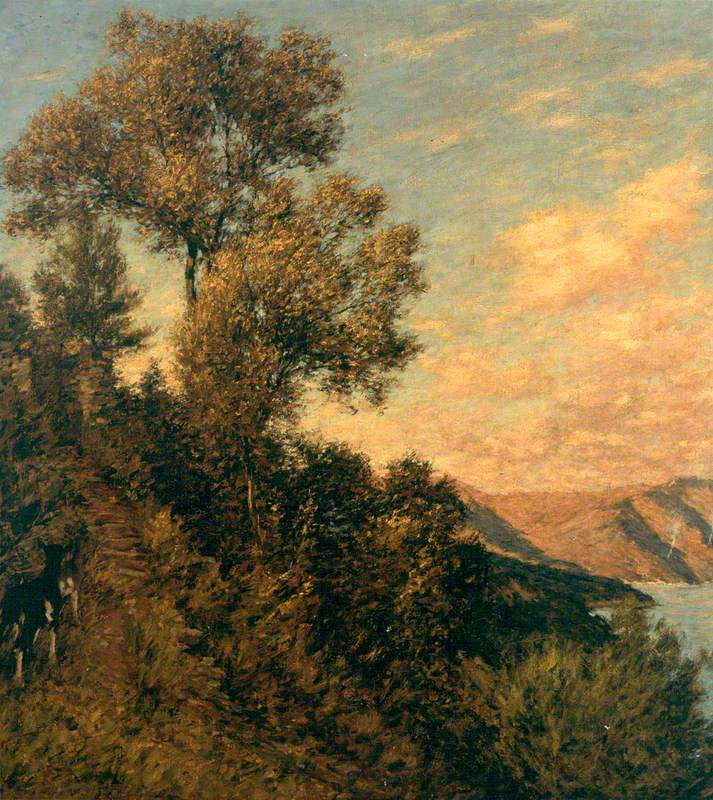Can you explain why the artist might have chosen this particular perspective and composition? The artist's choice of perspective, placing the tree dramatically at the edge of the cliff with a sweeping view of the water, enhances the grandeur of the natural landscape. This composition draws the viewer's eye across the painting, from the rugged textures of the foreground to the soft, luminous sky and water in the background. Such a perspective might be intended to evoke a sense of awe and emphasize the sublime beauty of unspoiled nature, common themes in landscape art during the 19th century. 